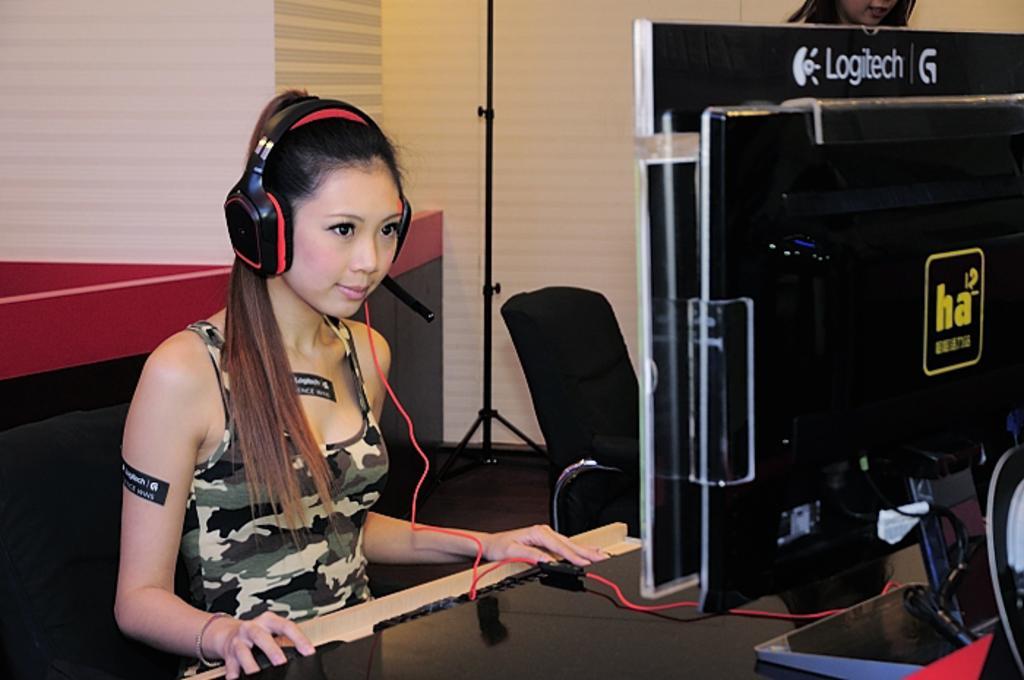Can you describe this image briefly? In this image, we can see a lady sitting on the chair and wearing a headset. In the background, we can see boards, cabins, stands, a mic and there are some other objects and we can see an other lady and a wall. 